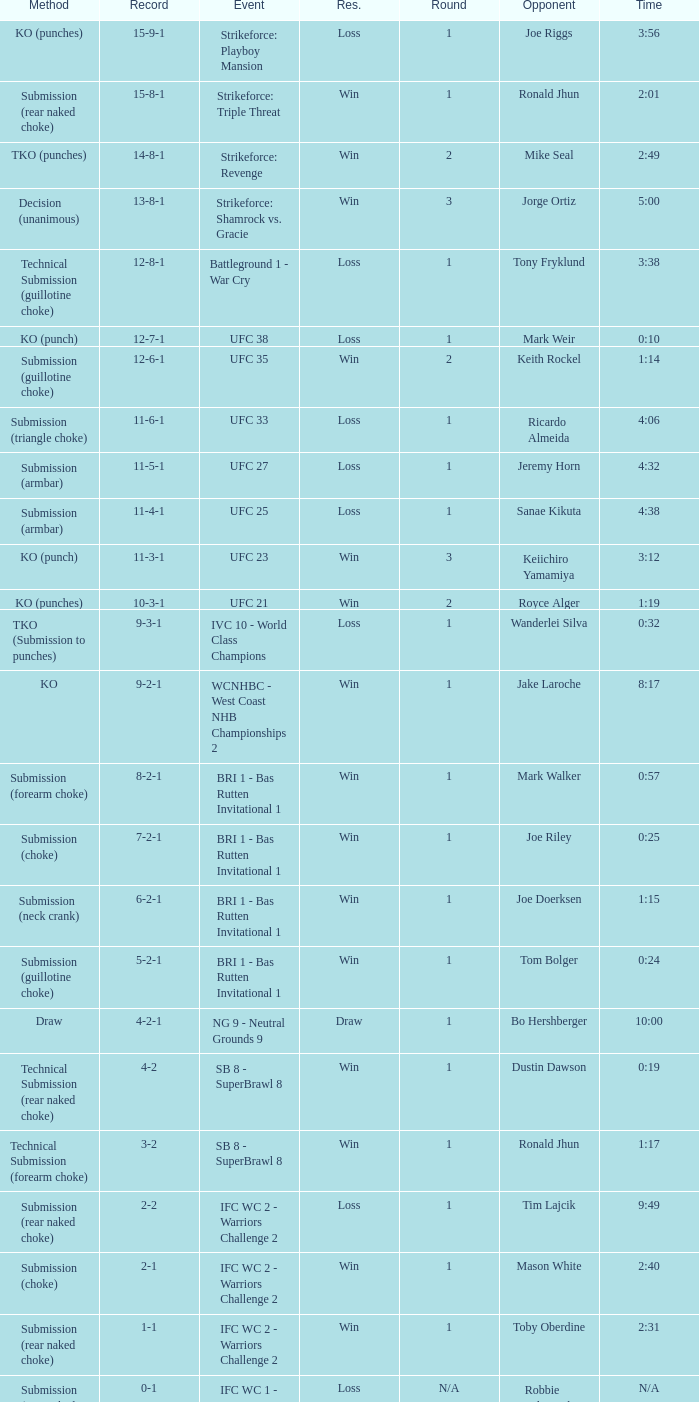Who was the opponent when the fight had a time of 2:01? Ronald Jhun. 